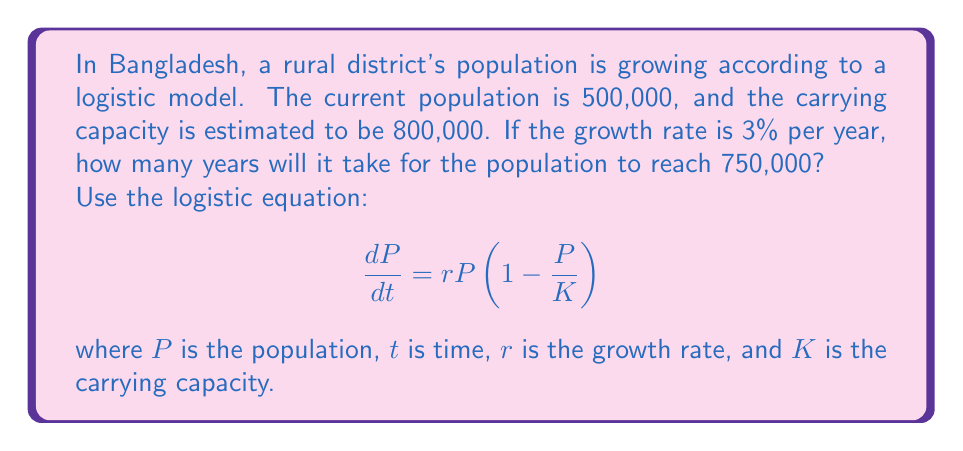Give your solution to this math problem. To solve this problem, we'll use the solution to the logistic equation:

$$P(t) = \frac{K}{1 + (\frac{K}{P_0} - 1)e^{-rt}}$$

where $P_0$ is the initial population.

Given:
$P_0 = 500,000$
$K = 800,000$
$r = 0.03$ (3% per year)
$P(t) = 750,000$ (target population)

Step 1: Substitute the values into the equation:
$$750,000 = \frac{800,000}{1 + (\frac{800,000}{500,000} - 1)e^{-0.03t}}$$

Step 2: Simplify:
$$750,000 = \frac{800,000}{1 + 0.6e^{-0.03t}}$$

Step 3: Multiply both sides by $(1 + 0.6e^{-0.03t})$:
$$750,000(1 + 0.6e^{-0.03t}) = 800,000$$

Step 4: Distribute:
$$750,000 + 450,000e^{-0.03t} = 800,000$$

Step 5: Subtract 750,000 from both sides:
$$450,000e^{-0.03t} = 50,000$$

Step 6: Divide both sides by 450,000:
$$e^{-0.03t} = \frac{1}{9}$$

Step 7: Take the natural logarithm of both sides:
$$-0.03t = \ln(\frac{1}{9})$$

Step 8: Solve for t:
$$t = -\frac{\ln(\frac{1}{9})}{0.03} \approx 73.0$$

Therefore, it will take approximately 73 years for the population to reach 750,000.
Answer: 73 years 